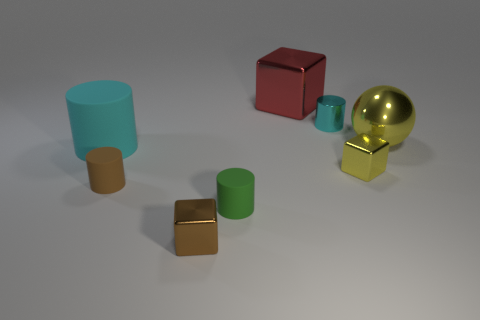How many tiny things are both in front of the tiny brown matte thing and behind the large cyan thing? Upon inspecting the image, there are no tiny objects that are both in front of the tiny brown matte object and behind the large cyan object. Every small item is either only in front of the tiny brown matte object or only behind the large cyan one, with none meeting both conditions. 